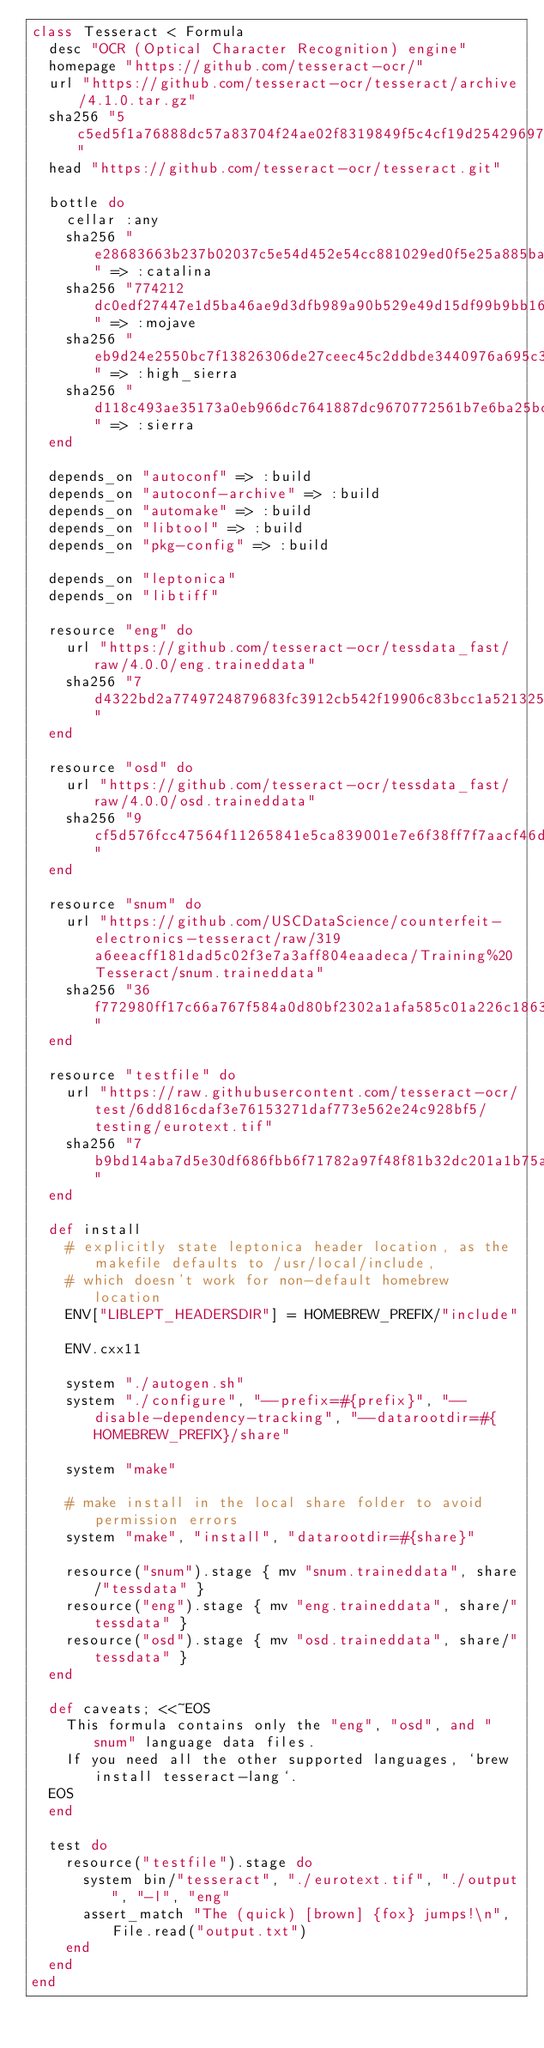Convert code to text. <code><loc_0><loc_0><loc_500><loc_500><_Ruby_>class Tesseract < Formula
  desc "OCR (Optical Character Recognition) engine"
  homepage "https://github.com/tesseract-ocr/"
  url "https://github.com/tesseract-ocr/tesseract/archive/4.1.0.tar.gz"
  sha256 "5c5ed5f1a76888dc57a83704f24ae02f8319849f5c4cf19d254296978a1a1961"
  head "https://github.com/tesseract-ocr/tesseract.git"

  bottle do
    cellar :any
    sha256 "e28683663b237b02037c5e54d452e54cc881029ed0f5e25a885ba6bb804440e2" => :catalina
    sha256 "774212dc0edf27447e1d5ba46ae9d3dfb989a90b529e49d15df99b9bb16e73d7" => :mojave
    sha256 "eb9d24e2550bc7f13826306de27ceec45c2ddbde3440976a695c33daefbb204d" => :high_sierra
    sha256 "d118c493ae35173a0eb966dc7641887dc9670772561b7e6ba25bccf4bdaab384" => :sierra
  end

  depends_on "autoconf" => :build
  depends_on "autoconf-archive" => :build
  depends_on "automake" => :build
  depends_on "libtool" => :build
  depends_on "pkg-config" => :build

  depends_on "leptonica"
  depends_on "libtiff"

  resource "eng" do
    url "https://github.com/tesseract-ocr/tessdata_fast/raw/4.0.0/eng.traineddata"
    sha256 "7d4322bd2a7749724879683fc3912cb542f19906c83bcc1a52132556427170b2"
  end

  resource "osd" do
    url "https://github.com/tesseract-ocr/tessdata_fast/raw/4.0.0/osd.traineddata"
    sha256 "9cf5d576fcc47564f11265841e5ca839001e7e6f38ff7f7aacf46d15a96b00ff"
  end

  resource "snum" do
    url "https://github.com/USCDataScience/counterfeit-electronics-tesseract/raw/319a6eeacff181dad5c02f3e7a3aff804eaadeca/Training%20Tesseract/snum.traineddata"
    sha256 "36f772980ff17c66a767f584a0d80bf2302a1afa585c01a226c1863afcea1392"
  end

  resource "testfile" do
    url "https://raw.githubusercontent.com/tesseract-ocr/test/6dd816cdaf3e76153271daf773e562e24c928bf5/testing/eurotext.tif"
    sha256 "7b9bd14aba7d5e30df686fbb6f71782a97f48f81b32dc201a1b75afe6de747d6"
  end

  def install
    # explicitly state leptonica header location, as the makefile defaults to /usr/local/include,
    # which doesn't work for non-default homebrew location
    ENV["LIBLEPT_HEADERSDIR"] = HOMEBREW_PREFIX/"include"

    ENV.cxx11

    system "./autogen.sh"
    system "./configure", "--prefix=#{prefix}", "--disable-dependency-tracking", "--datarootdir=#{HOMEBREW_PREFIX}/share"

    system "make"

    # make install in the local share folder to avoid permission errors
    system "make", "install", "datarootdir=#{share}"

    resource("snum").stage { mv "snum.traineddata", share/"tessdata" }
    resource("eng").stage { mv "eng.traineddata", share/"tessdata" }
    resource("osd").stage { mv "osd.traineddata", share/"tessdata" }
  end

  def caveats; <<~EOS
    This formula contains only the "eng", "osd", and "snum" language data files.
    If you need all the other supported languages, `brew install tesseract-lang`.
  EOS
  end

  test do
    resource("testfile").stage do
      system bin/"tesseract", "./eurotext.tif", "./output", "-l", "eng"
      assert_match "The (quick) [brown] {fox} jumps!\n", File.read("output.txt")
    end
  end
end
</code> 